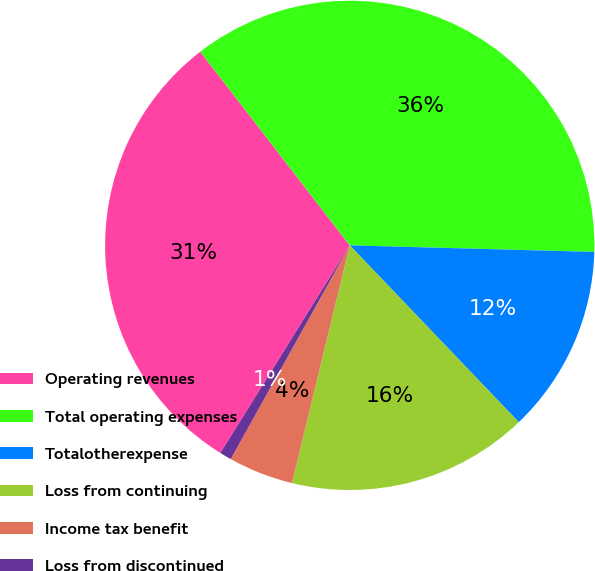Convert chart. <chart><loc_0><loc_0><loc_500><loc_500><pie_chart><fcel>Operating revenues<fcel>Total operating expenses<fcel>Totalotherexpense<fcel>Loss from continuing<fcel>Income tax benefit<fcel>Loss from discontinued<nl><fcel>30.67%<fcel>35.89%<fcel>12.43%<fcel>15.94%<fcel>4.29%<fcel>0.78%<nl></chart> 